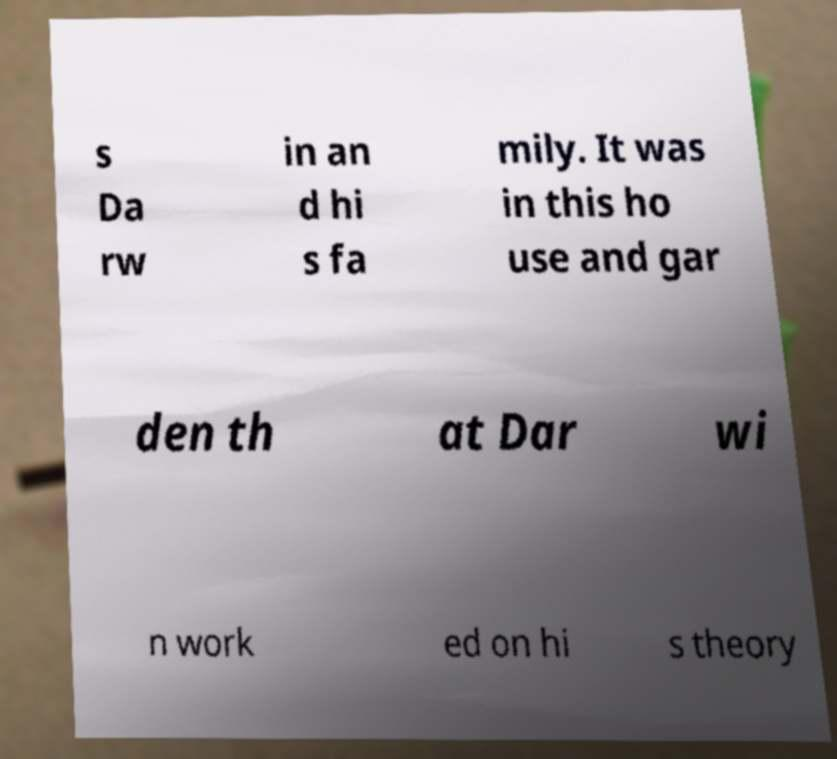I need the written content from this picture converted into text. Can you do that? s Da rw in an d hi s fa mily. It was in this ho use and gar den th at Dar wi n work ed on hi s theory 